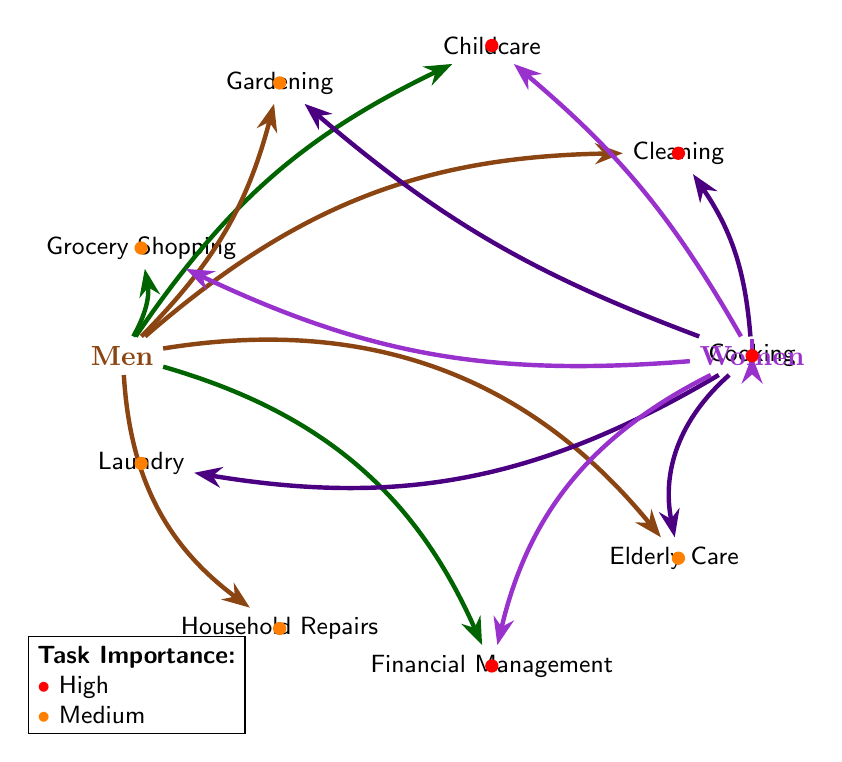What participants are involved in Cooking? The diagram shows an arrow pointing from the women node to the Cooking task node, indicating that Cooking is performed solely by Women.
Answer: Women Which task is associated with both Men and Women? Looking at the diagram, I can see that there are arrows indicating participation from both Men and Women for the Cleaning, Childcare, Grocery Shopping, Elderly Care, and Financial Management tasks.
Answer: Cleaning, Childcare, Grocery Shopping, Elderly Care, Financial Management How many tasks are labeled as High importance? By counting the task nodes that have a red dot indicating High importance, we find there are five such tasks: Cooking, Cleaning, Childcare, Financial Management, and Elderly Care.
Answer: 5 Which task is exclusively performed by Men? The diagram shows only one task node, Household Repairs, with an arrow pointing from the Men node.
Answer: Household Repairs Which tasks do Women participate in besides Cooking? Inspecting the diagram, Women are involved in Cleaning, Childcare, Gardening, Grocery Shopping, Laundry, Financial Management, and Elderly Care, which can be counted based on the connecting arrows.
Answer: Cleaning, Childcare, Gardening, Grocery Shopping, Laundry, Financial Management, Elderly Care What task has the fewest participants according to the diagram? By reviewing the connections, the task with only one participant is Cooking, as it is performed solely by Women.
Answer: Cooking What is the importance level of Gardening? The diagram has an orange dot next to the Gardening task, indicating it carries Medium importance.
Answer: Medium How many tasks are involved in Financial Management? There is one task node for Financial Management, which shows connections to both Men and Women, indicating that there’s only one specific task categorized within that area.
Answer: 1 Which two tasks do both Men and Women take part in that are marked as High importance? The diagram indicates the tasks of Childcare and Elderly Care have connections from both the Men and Women nodes, and they are marked with red dots for High importance.
Answer: Childcare, Elderly Care 